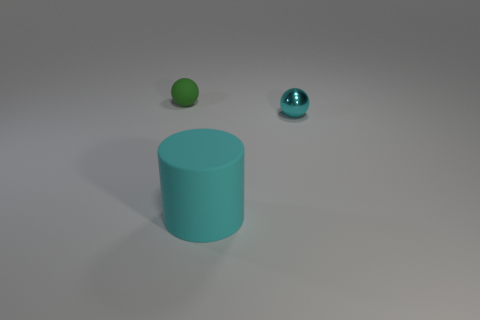There is a big cylinder that is the same color as the shiny object; what is its material?
Provide a succinct answer. Rubber. Does the tiny ball in front of the tiny green rubber thing have the same color as the matte object that is in front of the tiny green rubber sphere?
Your answer should be very brief. Yes. There is a rubber object that is in front of the tiny green rubber ball; is it the same color as the metal sphere?
Ensure brevity in your answer.  Yes. What size is the other object that is the same color as the big rubber thing?
Your response must be concise. Small. What shape is the metal object that is the same color as the large cylinder?
Your response must be concise. Sphere. There is a big object; does it have the same color as the sphere that is on the left side of the large cylinder?
Offer a very short reply. No. Is the number of large objects that are left of the big cyan cylinder less than the number of large cyan metal balls?
Make the answer very short. No. There is a ball behind the tiny cyan object; what is it made of?
Offer a very short reply. Rubber. What number of other objects are the same size as the metallic thing?
Give a very brief answer. 1. Is the size of the rubber cylinder the same as the ball on the right side of the green matte thing?
Give a very brief answer. No. 